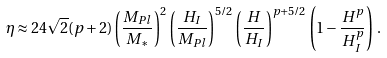Convert formula to latex. <formula><loc_0><loc_0><loc_500><loc_500>\eta \approx 2 4 \sqrt { 2 } ( p + 2 ) \left ( \frac { M _ { P l } } { M _ { * } } \right ) ^ { 2 } \left ( \frac { H _ { I } } { M _ { P l } } \right ) ^ { 5 / 2 } \left ( \frac { H } { H _ { I } } \right ) ^ { p + 5 / 2 } \left ( 1 - \frac { H ^ { p } } { H _ { I } ^ { p } } \right ) \, .</formula> 